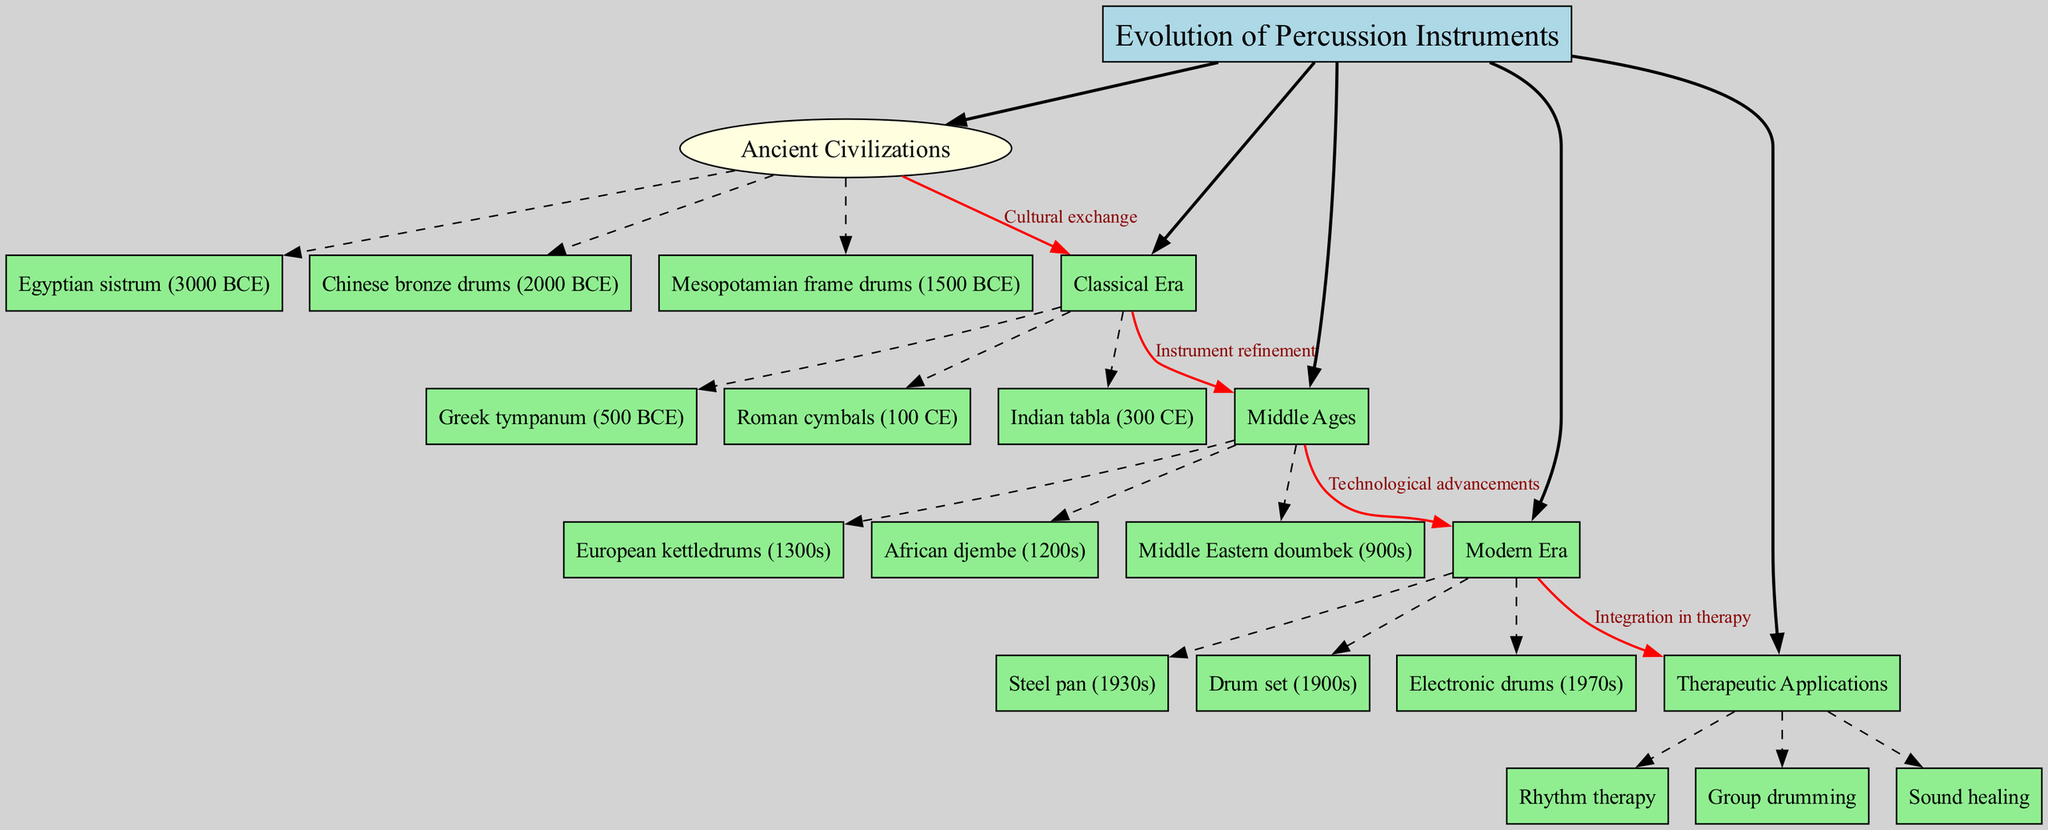What is the central theme of the diagram? The central theme is explicitly stated at the top of the diagram and identifies what the entire diagram is focused on. In this case, it is "Evolution of Percussion Instruments."
Answer: Evolution of Percussion Instruments How many main branches are shown in the diagram? By counting the main branches listed beneath the central theme, we can identify that there are five distinct branches, which are: Ancient Civilizations, Classical Era, Middle Ages, Modern Era, and Therapeutic Applications.
Answer: 5 Which percussion instrument is associated with the year 3000 BCE? Looking at the sub-branches under the "Ancient Civilizations" main branch, the Egyptian sistrum is specifically listed as originating in 3000 BCE.
Answer: Egyptian sistrum What connects the Classical Era to the Middle Ages? The connections between branches highlight relationships, and in this instance, the label for the arrow connecting "Classical Era" to "Middle Ages" is "Instrument refinement."
Answer: Instrument refinement Identify one sub-branch under the Modern Era. Under the "Modern Era" branch, there are three sub-branches listed; for instance, the "Drum set" is one of those sub-branches.
Answer: Drum set What is the relationship labeled between the Modern Era and Therapeutic Applications? To understand the connection between these two branches, we look for the connecting arrow, which reveals that it is labeled "Integration in therapy."
Answer: Integration in therapy Which percussion instrument is from the Middle Ages? Referring to the "Middle Ages" branch, we can identify that the African djembe is one of the instruments associated with that period.
Answer: African djembe What is a therapeutic application mentioned in the diagram? Within the "Therapeutic Applications" main branch, we can find several listed applications; for instance, "Rhythm therapy" is one of them.
Answer: Rhythm therapy How does the diagram show the concept of cultural exchange? The term "Cultural exchange" is indicated as the label for the arrow connecting "Ancient Civilizations" to "Classical Era," showcasing how influences were shared between these periods.
Answer: Cultural exchange Which era introduced electronic drums? In examining the sub-branches under the "Modern Era," we see that electronic drums are specifically mentioned as having emerged in the 1970s.
Answer: 1970s 